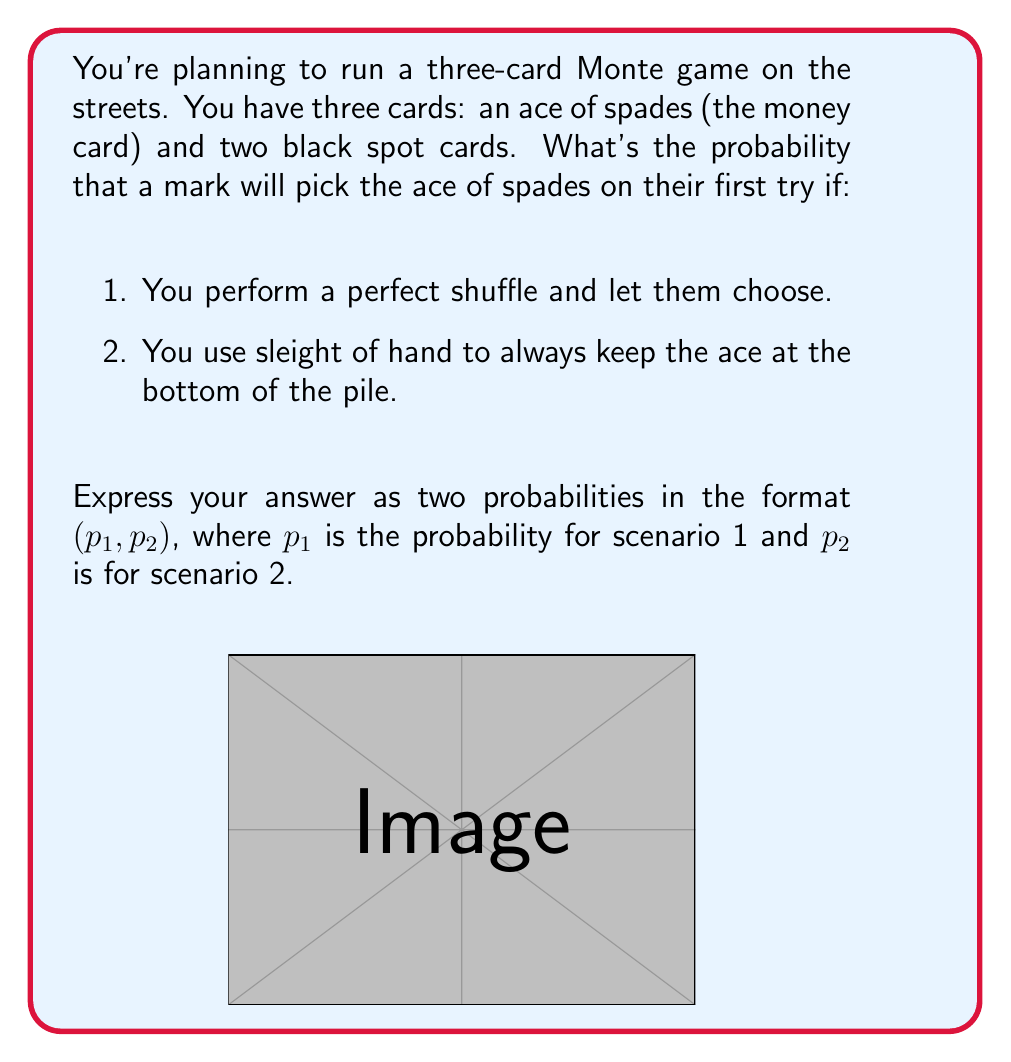Can you answer this question? Let's break this down step-by-step:

1. Perfect shuffle scenario:
   In this case, the ace of spades has an equal chance of being in any of the three positions.
   The probability of choosing the ace is:
   $$P(\text{choosing ace}) = \frac{\text{favorable outcomes}}{\text{total outcomes}} = \frac{1}{3}$$

2. Sleight of hand scenario:
   Here, you're manipulating the cards so that the ace is always at the bottom.
   The probability of the mark choosing the ace depends on whether they tend to pick the bottom card or not.
   However, from a purely mathematical standpoint, if the mark's choice is truly random among the three positions, the probability remains:
   $$P(\text{choosing ace}) = \frac{1}{3}$$

   Note: In reality, this scenario gives you, the grifter, control over the outcome. If you know the mark's tendencies (e.g., they usually avoid the bottom card), you can adjust the ace's position accordingly.

Therefore, the probabilities for both scenarios are the same mathematically, but scenario 2 gives you more control in practice.
Answer: $(\frac{1}{3}, \frac{1}{3})$ 